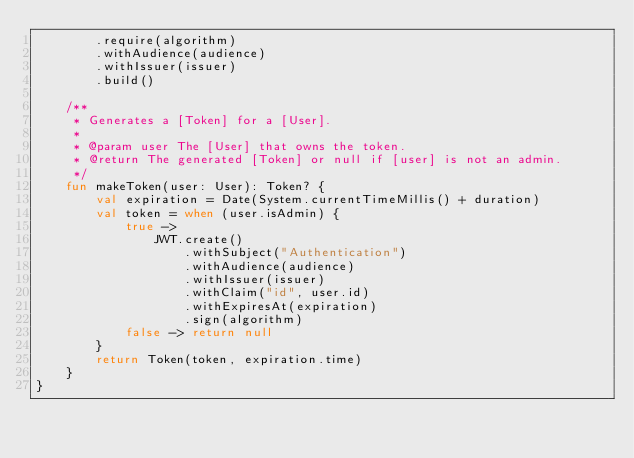Convert code to text. <code><loc_0><loc_0><loc_500><loc_500><_Kotlin_>        .require(algorithm)
        .withAudience(audience)
        .withIssuer(issuer)
        .build()

    /**
     * Generates a [Token] for a [User].
     *
     * @param user The [User] that owns the token.
     * @return The generated [Token] or null if [user] is not an admin.
     */
    fun makeToken(user: User): Token? {
        val expiration = Date(System.currentTimeMillis() + duration)
        val token = when (user.isAdmin) {
            true ->
                JWT.create()
                    .withSubject("Authentication")
                    .withAudience(audience)
                    .withIssuer(issuer)
                    .withClaim("id", user.id)
                    .withExpiresAt(expiration)
                    .sign(algorithm)
            false -> return null
        }
        return Token(token, expiration.time)
    }
}
</code> 